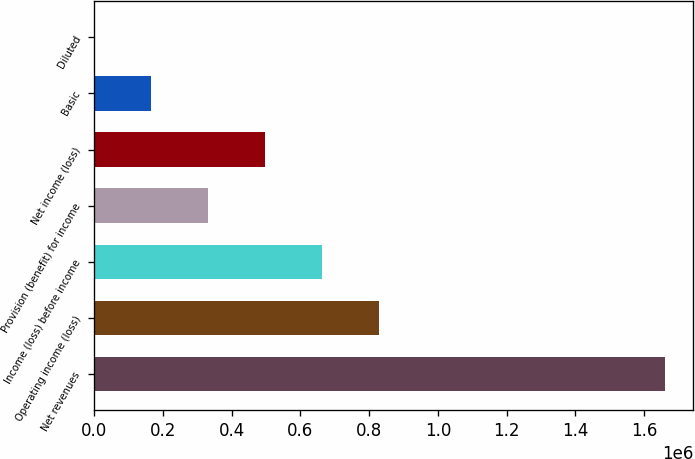Convert chart to OTSL. <chart><loc_0><loc_0><loc_500><loc_500><bar_chart><fcel>Net revenues<fcel>Operating income (loss)<fcel>Income (loss) before income<fcel>Provision (benefit) for income<fcel>Net income (loss)<fcel>Basic<fcel>Diluted<nl><fcel>1.65936e+06<fcel>829679<fcel>663743<fcel>331872<fcel>497807<fcel>165936<fcel>0.1<nl></chart> 